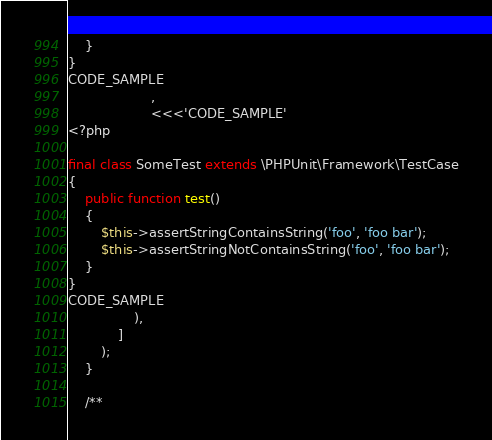Convert code to text. <code><loc_0><loc_0><loc_500><loc_500><_PHP_>    }
}
CODE_SAMPLE
                    ,
                    <<<'CODE_SAMPLE'
<?php

final class SomeTest extends \PHPUnit\Framework\TestCase
{
    public function test()
    {
        $this->assertStringContainsString('foo', 'foo bar');
        $this->assertStringNotContainsString('foo', 'foo bar');
    }
}
CODE_SAMPLE
                ),
            ]
        );
    }

    /**</code> 